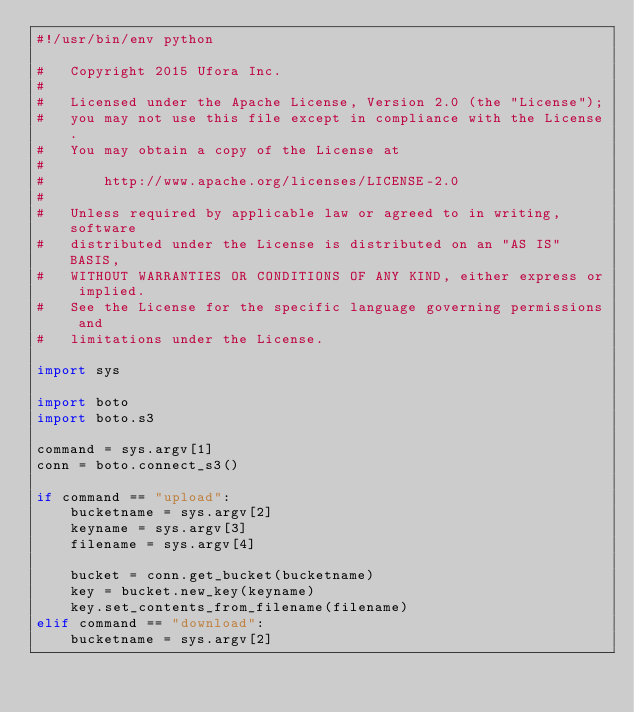Convert code to text. <code><loc_0><loc_0><loc_500><loc_500><_Python_>#!/usr/bin/env python

#   Copyright 2015 Ufora Inc.
#
#   Licensed under the Apache License, Version 2.0 (the "License");
#   you may not use this file except in compliance with the License.
#   You may obtain a copy of the License at
#
#       http://www.apache.org/licenses/LICENSE-2.0
#
#   Unless required by applicable law or agreed to in writing, software
#   distributed under the License is distributed on an "AS IS" BASIS,
#   WITHOUT WARRANTIES OR CONDITIONS OF ANY KIND, either express or implied.
#   See the License for the specific language governing permissions and
#   limitations under the License.

import sys

import boto
import boto.s3

command = sys.argv[1]
conn = boto.connect_s3()

if command == "upload":
    bucketname = sys.argv[2]
    keyname = sys.argv[3]
    filename = sys.argv[4]

    bucket = conn.get_bucket(bucketname)
    key = bucket.new_key(keyname)
    key.set_contents_from_filename(filename)
elif command == "download":
    bucketname = sys.argv[2]</code> 